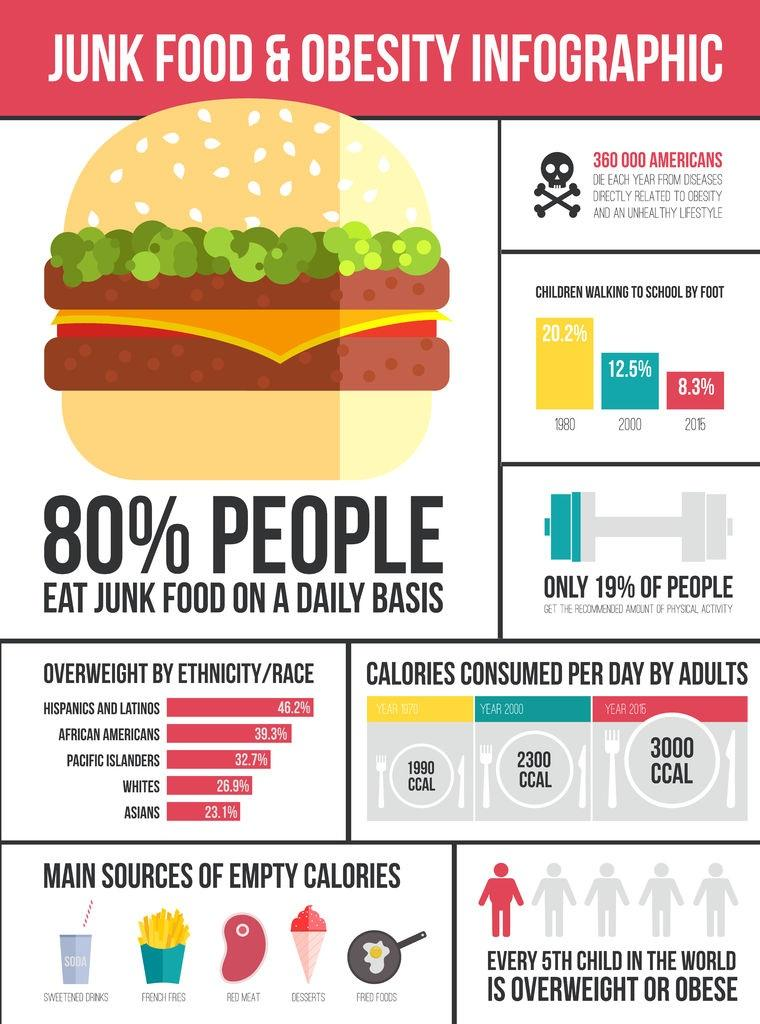Mention a couple of crucial points in this snapshot. According to data, African Americans have the highest percentage of overweight individuals among all ethnic groups in America. Pacific Islanders have the highest percentage of overweight individuals among all ethnic groups in America, at 32.7%. According to a recent study, 26.9% of white individuals in America are considered to be overweight. In the year 2016, the average amount of calories consumed per day by adults in America was approximately 3000 calories. In the year 2000, the average amount of calories consumed per day by adults in America was approximately 2300 calories. 